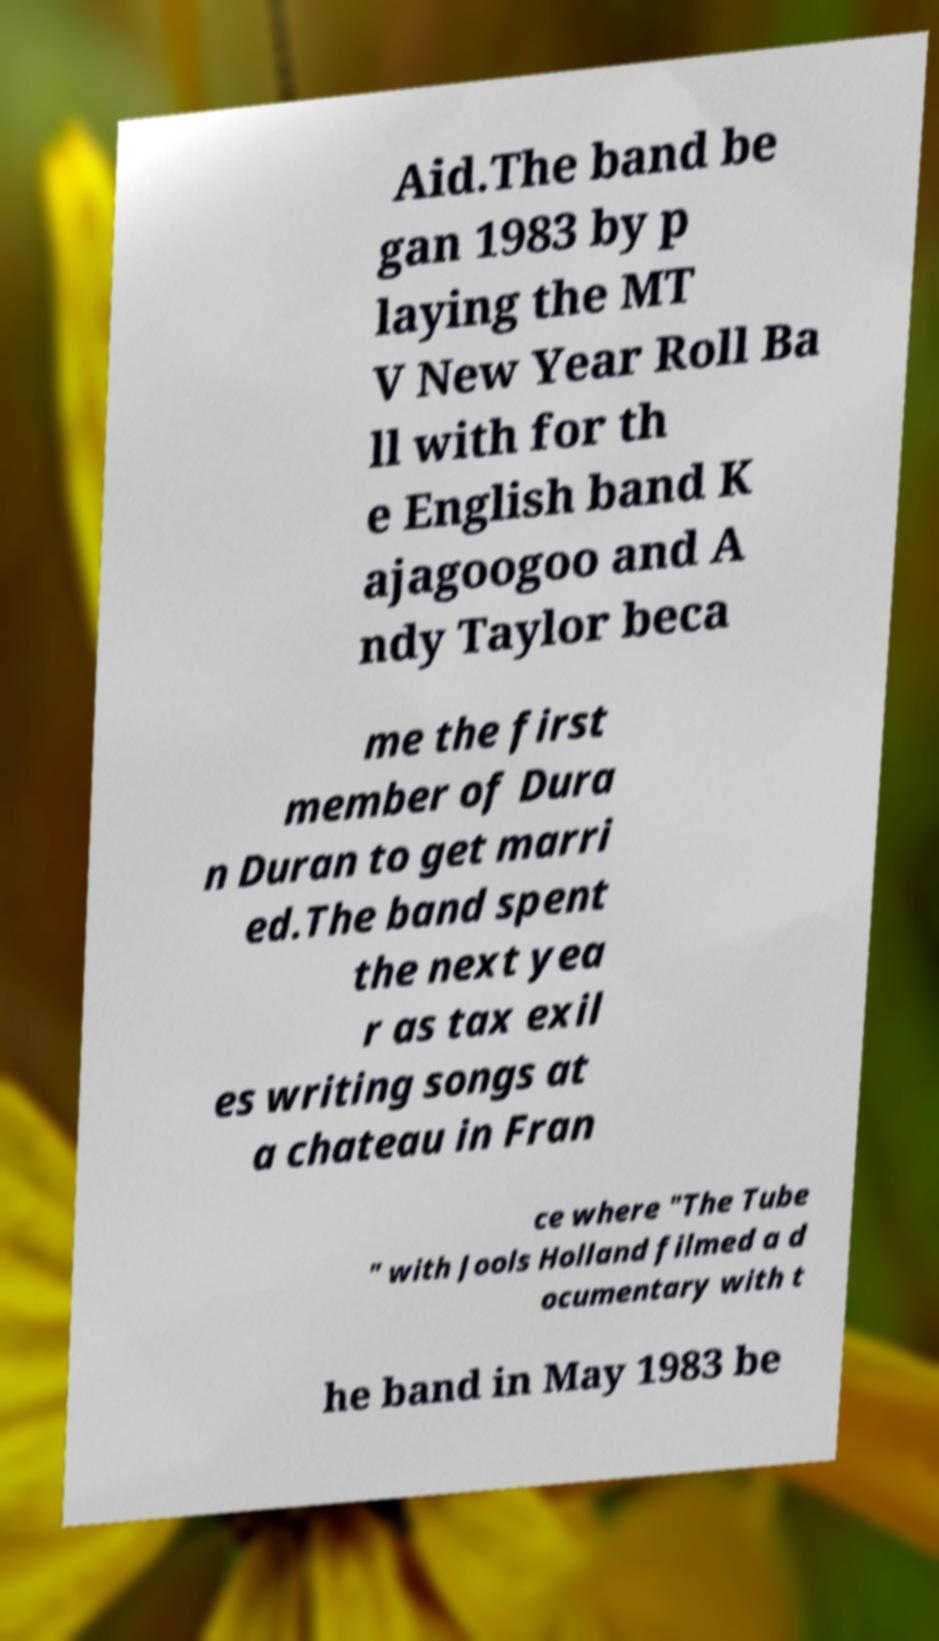What messages or text are displayed in this image? I need them in a readable, typed format. Aid.The band be gan 1983 by p laying the MT V New Year Roll Ba ll with for th e English band K ajagoogoo and A ndy Taylor beca me the first member of Dura n Duran to get marri ed.The band spent the next yea r as tax exil es writing songs at a chateau in Fran ce where "The Tube " with Jools Holland filmed a d ocumentary with t he band in May 1983 be 